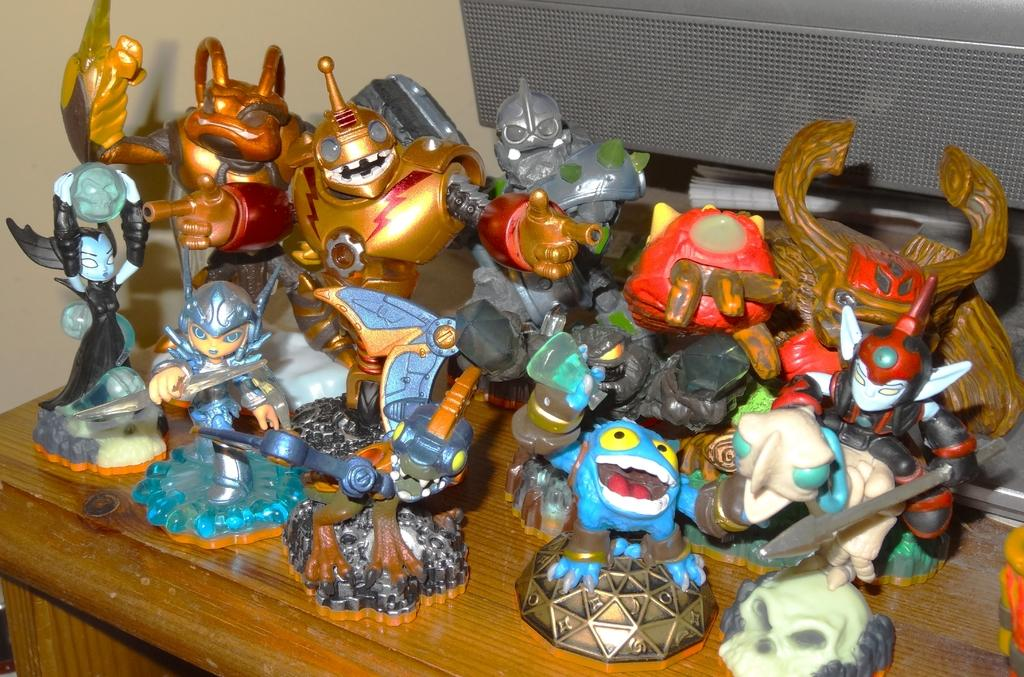What is located at the bottom of the image? There is a table at the bottom of the image. What is on the table in the image? There are many toys on the table. What is located behind the toys on the table? There is a book behind the toys. What else is located behind the toys? There is an object behind the toys. What theory is being discussed by the visitor in the image? There is no visitor present in the image, and therefore no discussion or theory can be observed. What type of heat source is visible in the image? There is no heat source visible in the image. 